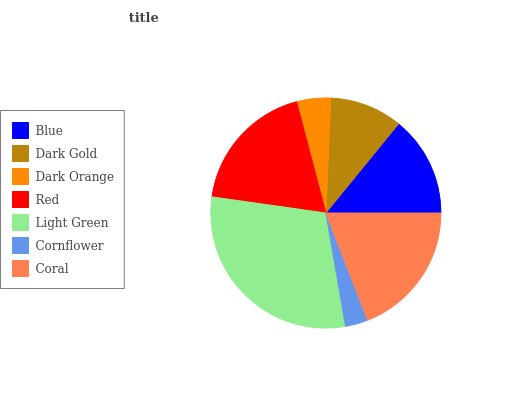Is Cornflower the minimum?
Answer yes or no. Yes. Is Light Green the maximum?
Answer yes or no. Yes. Is Dark Gold the minimum?
Answer yes or no. No. Is Dark Gold the maximum?
Answer yes or no. No. Is Blue greater than Dark Gold?
Answer yes or no. Yes. Is Dark Gold less than Blue?
Answer yes or no. Yes. Is Dark Gold greater than Blue?
Answer yes or no. No. Is Blue less than Dark Gold?
Answer yes or no. No. Is Blue the high median?
Answer yes or no. Yes. Is Blue the low median?
Answer yes or no. Yes. Is Dark Gold the high median?
Answer yes or no. No. Is Coral the low median?
Answer yes or no. No. 